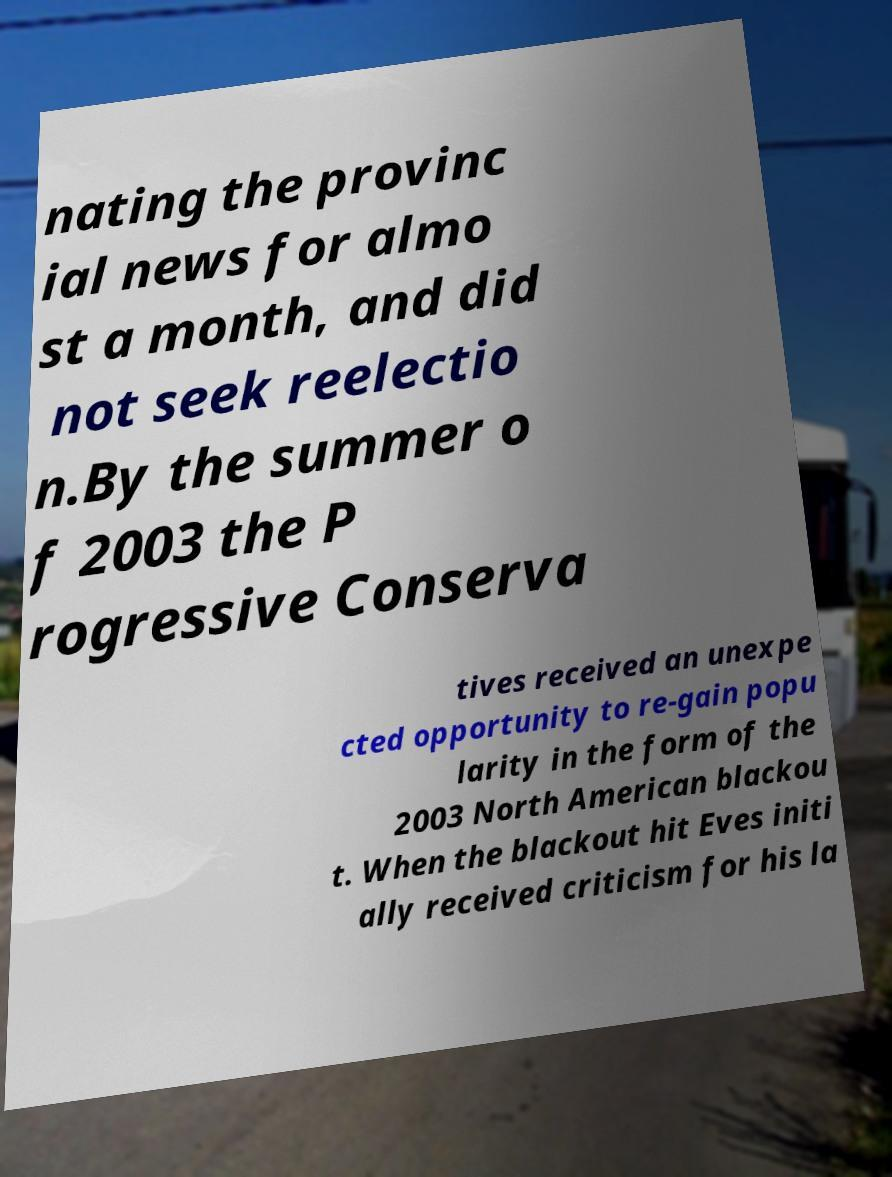Could you assist in decoding the text presented in this image and type it out clearly? nating the provinc ial news for almo st a month, and did not seek reelectio n.By the summer o f 2003 the P rogressive Conserva tives received an unexpe cted opportunity to re-gain popu larity in the form of the 2003 North American blackou t. When the blackout hit Eves initi ally received criticism for his la 